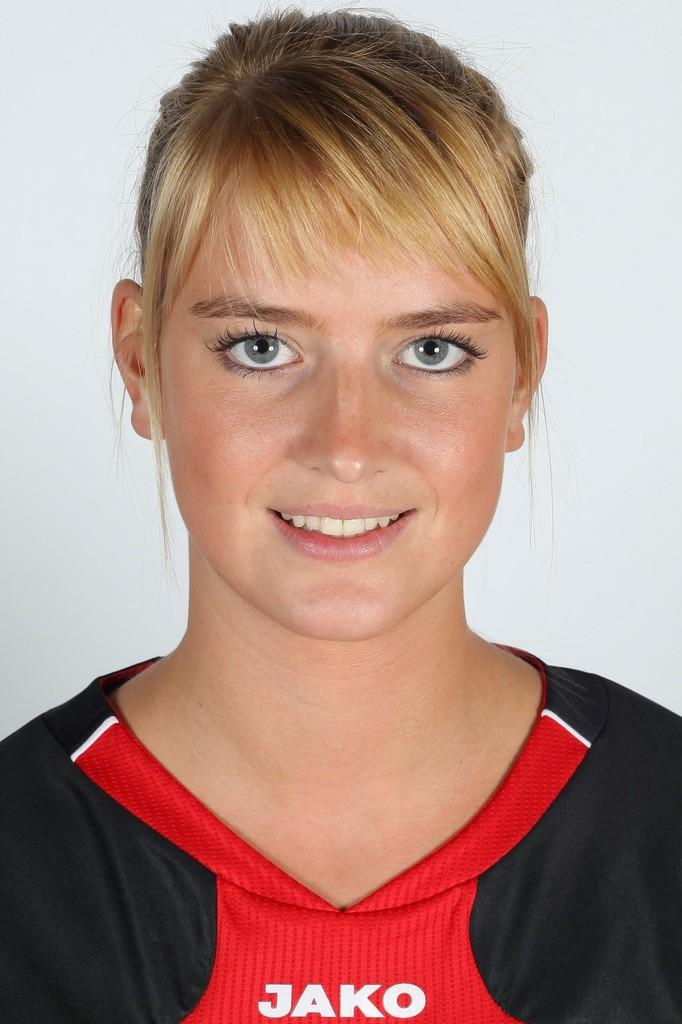<image>
Present a compact description of the photo's key features. A young woman is shown wearing a shirt with Jako on it. 